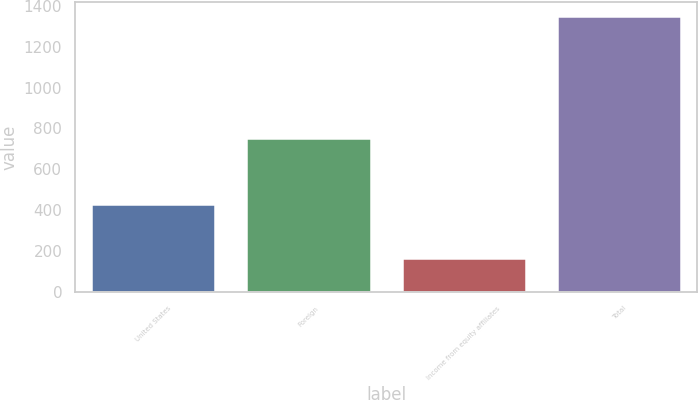Convert chart to OTSL. <chart><loc_0><loc_0><loc_500><loc_500><bar_chart><fcel>United States<fcel>Foreign<fcel>Income from equity affiliates<fcel>Total<nl><fcel>428.5<fcel>754.1<fcel>167.8<fcel>1350.4<nl></chart> 